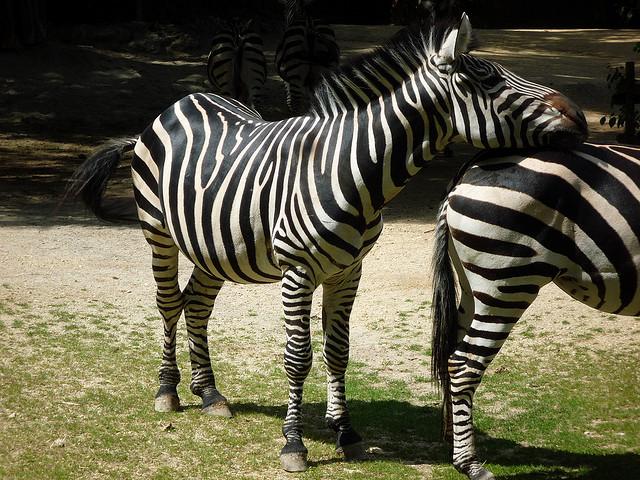How many white lines are on the two zebras?
Give a very brief answer. Lot. How many zebras are in the picture?
Short answer required. 2. Are these real animals?
Quick response, please. Yes. What type of zebra is this?
Be succinct. Black and white. Is the zebra in the sand?
Short answer required. No. What is the zebras in the back resting his face on?
Keep it brief. Zebra's back. 